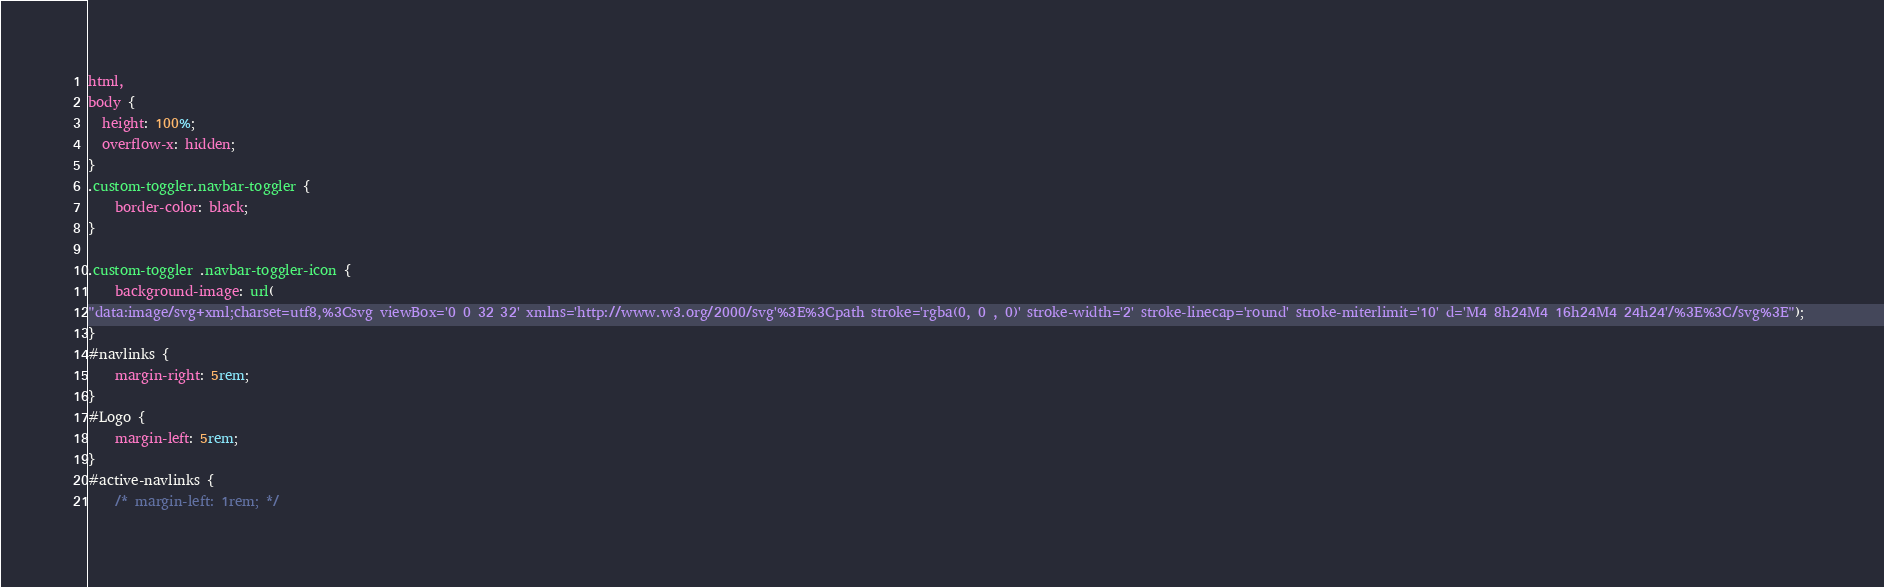<code> <loc_0><loc_0><loc_500><loc_500><_CSS_>html,
body {
  height: 100%;
  overflow-x: hidden;
}
.custom-toggler.navbar-toggler { 
    border-color: black; 
} 

.custom-toggler .navbar-toggler-icon { 
    background-image: url( 
"data:image/svg+xml;charset=utf8,%3Csvg viewBox='0 0 32 32' xmlns='http://www.w3.org/2000/svg'%3E%3Cpath stroke='rgba(0, 0 , 0)' stroke-width='2' stroke-linecap='round' stroke-miterlimit='10' d='M4 8h24M4 16h24M4 24h24'/%3E%3C/svg%3E"); 
} 
#navlinks {
    margin-right: 5rem;
}
#Logo {
    margin-left: 5rem;
}
#active-navlinks {
    /* margin-left: 1rem; */</code> 